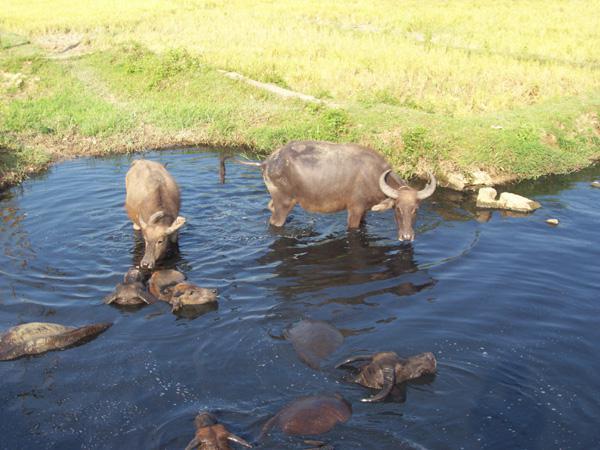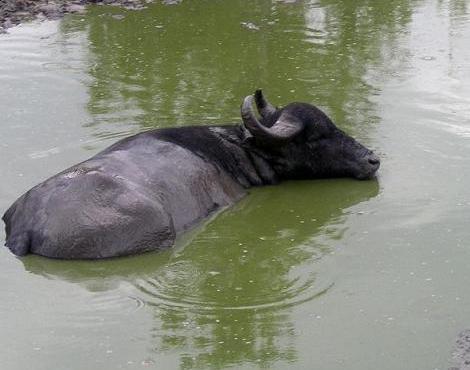The first image is the image on the left, the second image is the image on the right. Considering the images on both sides, is "There are three animals in total." valid? Answer yes or no. No. 